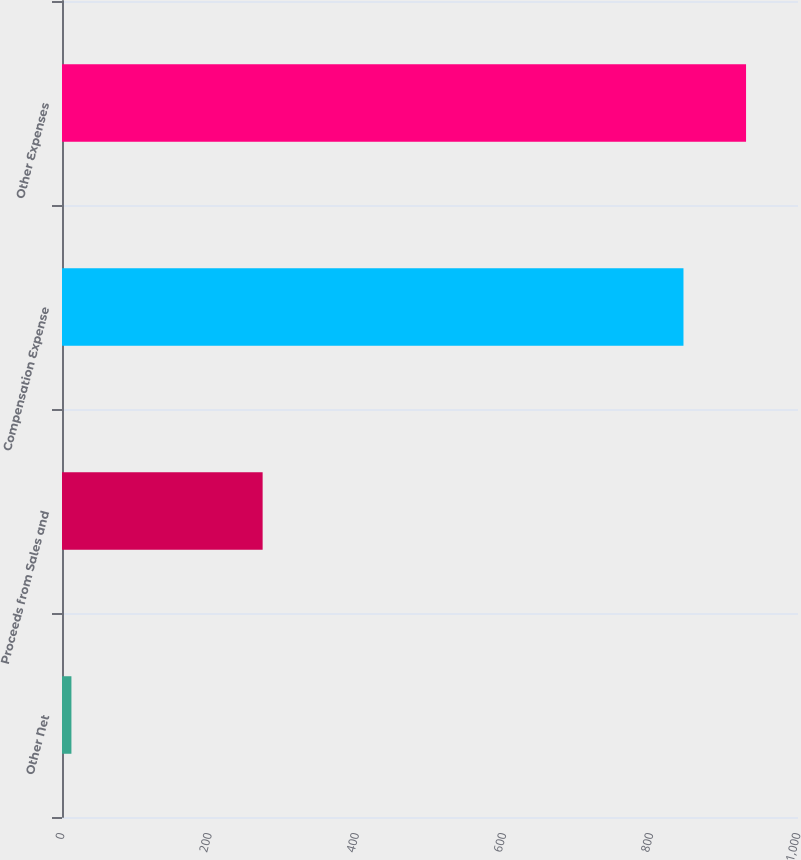<chart> <loc_0><loc_0><loc_500><loc_500><bar_chart><fcel>Other Net<fcel>Proceeds from Sales and<fcel>Compensation Expense<fcel>Other Expenses<nl><fcel>12.8<fcel>272.6<fcel>844.4<fcel>929.41<nl></chart> 